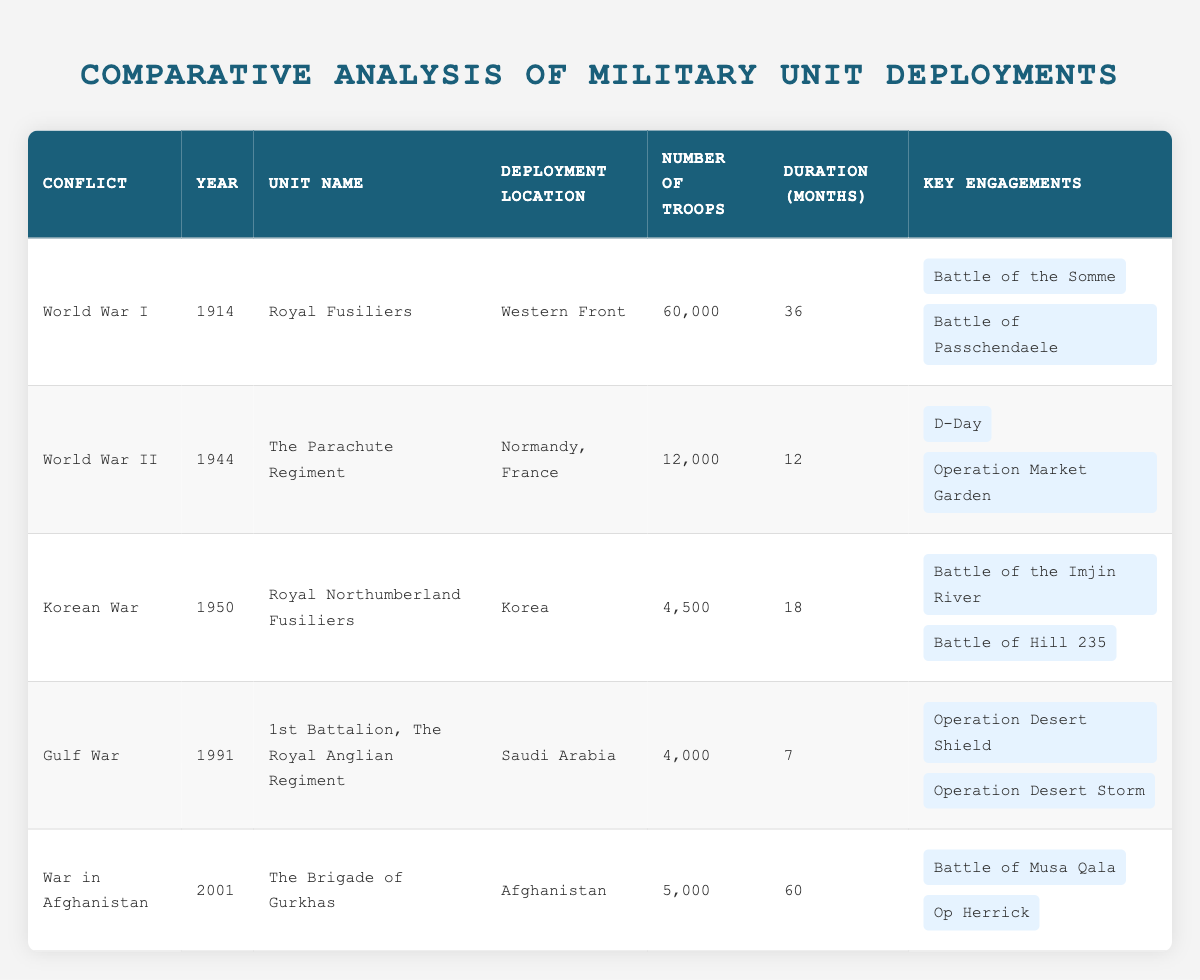What is the deployment location of The Parachute Regiment? From the table, we can locate The Parachute Regiment under the "Unit Name" column in the row for World War II, which indicates that its deployment location was "Normandy, France".
Answer: Normandy, France How many troops were deployed during the Gulf War? In the row for the Gulf War, we find that the number of troops deployed by the 1st Battalion, The Royal Anglian Regiment is listed as 4,000.
Answer: 4,000 Which military unit had the longest deployment duration? By examining the "Duration (Months)" column, we see that The Brigade of Gurkhas had a deployment duration of 60 months, which is longer than any other unit listed in the table.
Answer: The Brigade of Gurkhas What are the key engagements for the Royal Northumberland Fusiliers? We refer to the row corresponding to the Korean War under the "Unit Name" of the Royal Northumberland Fusiliers, where the key engagements are listed as: "Battle of the Imjin River" and "Battle of Hill 235".
Answer: Battle of the Imjin River, Battle of Hill 235 Is it true that the Royal Fusiliers had more than 50,000 troops deployed? Looking at the table, the number of troops for the Royal Fusiliers in World War I is 60,000, which is indeed more than 50,000, making this statement true.
Answer: True What was the total number of troops deployed across all conflicts listed? To find the total, we sum the number of troops from all entries: 60,000 (Royal Fusiliers) + 12,000 (The Parachute Regiment) + 4,500 (Royal Northumberland Fusiliers) + 4,000 (1st Battalion, The Royal Anglian Regiment) + 5,000 (The Brigade of Gurkhas) = 85,500.
Answer: 85,500 During which conflict was the fewest number of troops deployed? After reviewing the "Number of Troops" column, the lowest number is 4,000 troops during the Gulf War, indicating it had the fewest troops deployed among all listed conflicts.
Answer: Gulf War How many engagements did the troops participate in during World War I? We see that under World War I for the Royal Fusiliers, there are two engagements listed: "Battle of the Somme" and "Battle of Passchendaele". Therefore, they participated in two key engagements.
Answer: 2 